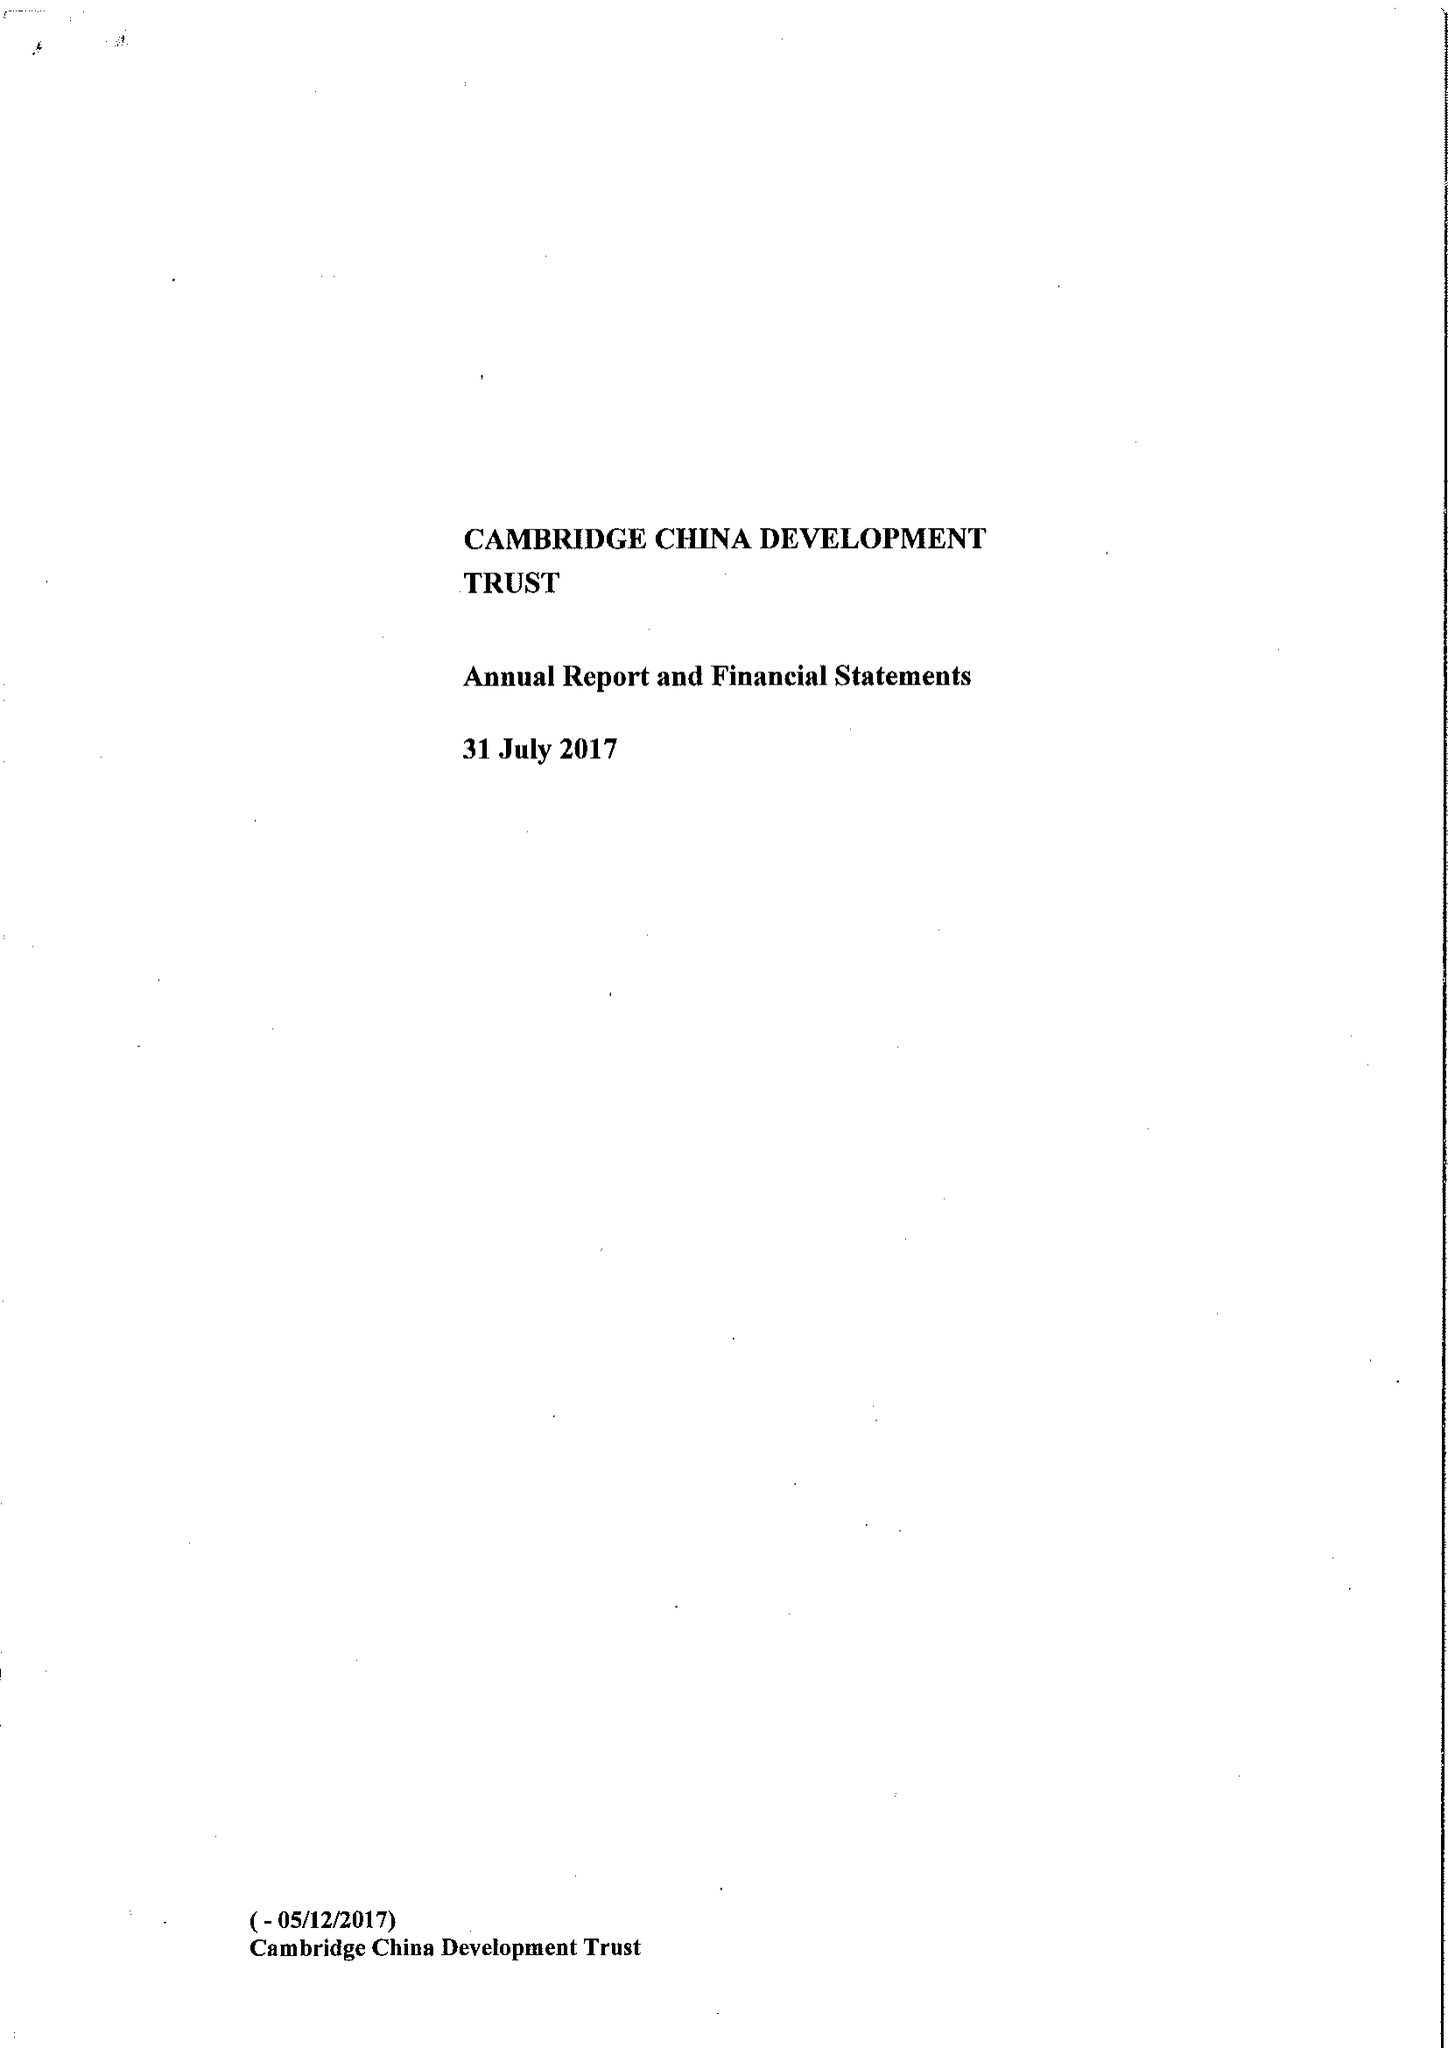What is the value for the income_annually_in_british_pounds?
Answer the question using a single word or phrase. 610634.00 